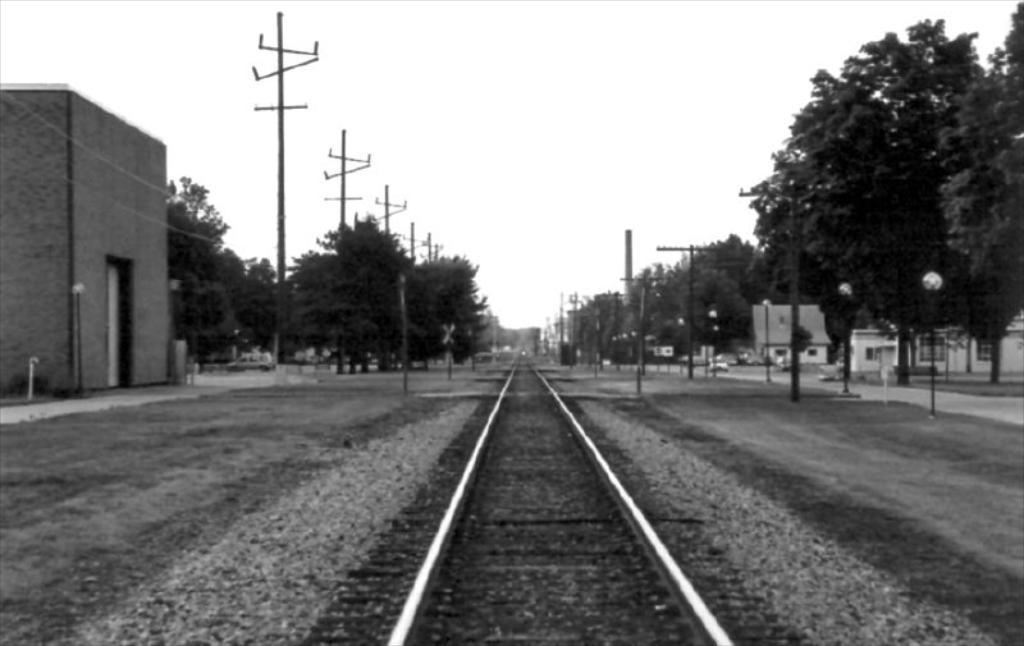Describe this image in one or two sentences. This picture shows a railway track and we see few buildings and poles and polite and we see trees and a car moving on the road. 